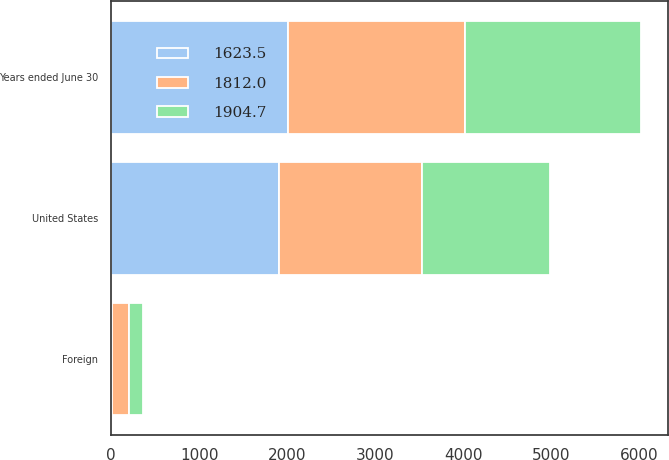Convert chart. <chart><loc_0><loc_0><loc_500><loc_500><stacked_bar_chart><ecel><fcel>Years ended June 30<fcel>United States<fcel>Foreign<nl><fcel>1623.5<fcel>2009<fcel>1908.6<fcel>3.9<nl><fcel>1812<fcel>2008<fcel>1618.6<fcel>193.4<nl><fcel>1904.7<fcel>2007<fcel>1457.4<fcel>166.1<nl></chart> 